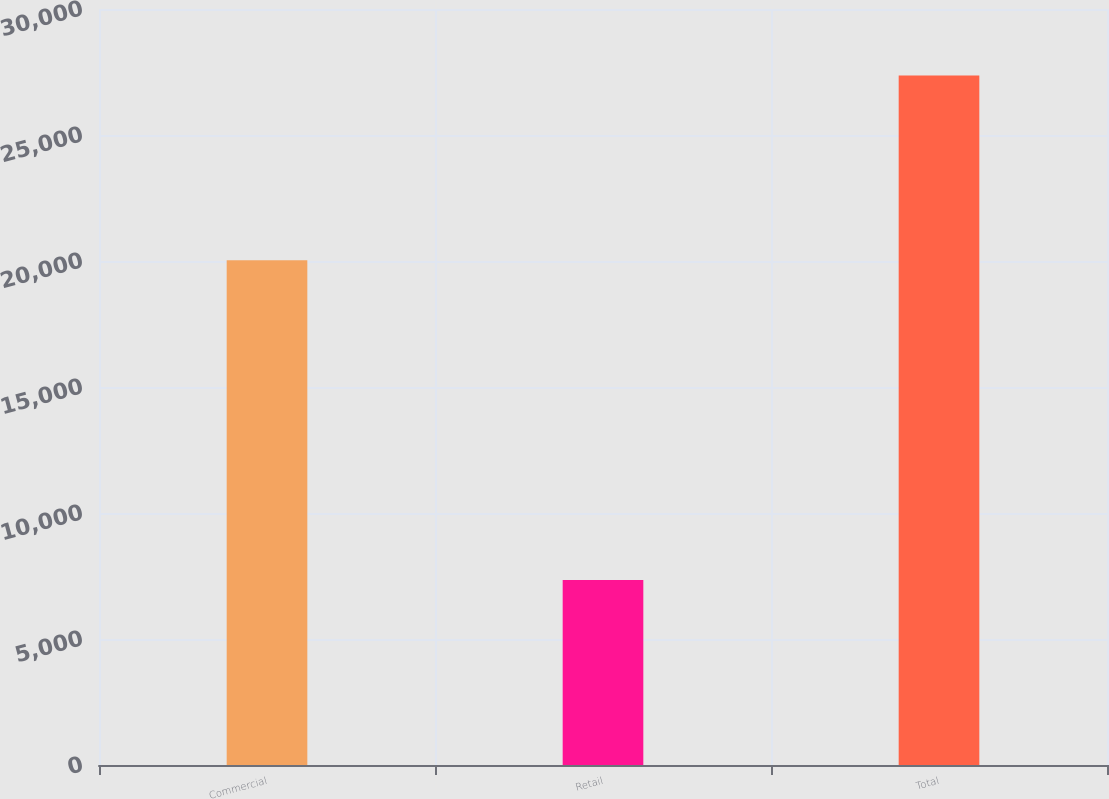Convert chart to OTSL. <chart><loc_0><loc_0><loc_500><loc_500><bar_chart><fcel>Commercial<fcel>Retail<fcel>Total<nl><fcel>20025.8<fcel>7336.4<fcel>27362.2<nl></chart> 